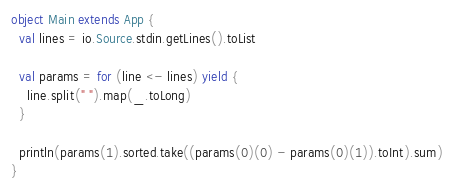Convert code to text. <code><loc_0><loc_0><loc_500><loc_500><_Scala_>object Main extends App {
  val lines = io.Source.stdin.getLines().toList

  val params = for (line <- lines) yield {
    line.split(" ").map(_.toLong)
  }

  println(params(1).sorted.take((params(0)(0) - params(0)(1)).toInt).sum)
}
</code> 